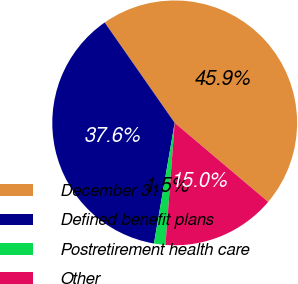<chart> <loc_0><loc_0><loc_500><loc_500><pie_chart><fcel>December 31<fcel>Defined benefit plans<fcel>Postretirement health care<fcel>Other<nl><fcel>45.86%<fcel>37.6%<fcel>1.51%<fcel>15.03%<nl></chart> 